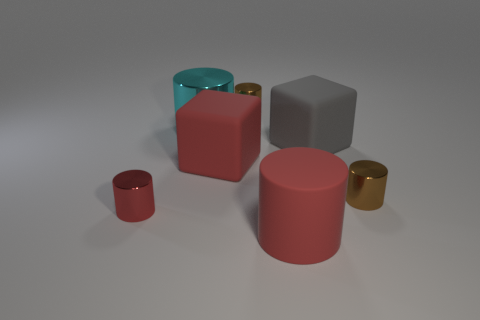Subtract all red metal cylinders. How many cylinders are left? 4 Add 1 big blue matte spheres. How many objects exist? 8 Subtract all brown spheres. How many brown cylinders are left? 2 Subtract all brown cylinders. How many cylinders are left? 3 Subtract all cylinders. How many objects are left? 2 Subtract 1 cylinders. How many cylinders are left? 4 Subtract 0 blue cylinders. How many objects are left? 7 Subtract all brown cylinders. Subtract all purple cubes. How many cylinders are left? 3 Subtract all tiny brown cylinders. Subtract all large cyan cylinders. How many objects are left? 4 Add 7 red rubber cylinders. How many red rubber cylinders are left? 8 